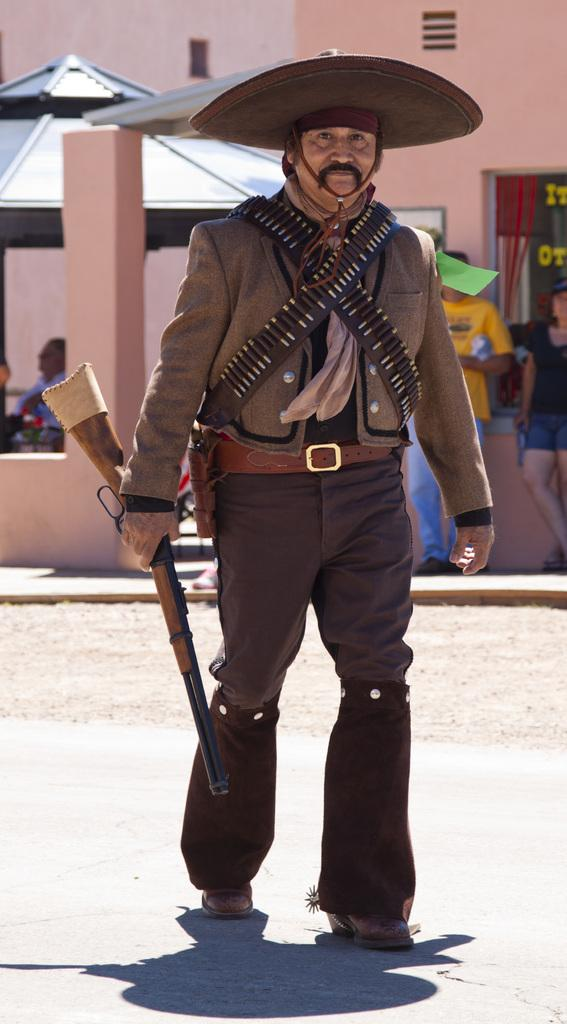What is the person in the image holding? The person is holding a gun in the image. Can you describe the person's attire? The person is wearing a hat in the image. What type of structures can be seen in the image? There is a building and a shed in the image. What else is present in the image besides the person and structures? There are objects and people in the image. What type of harmony is being played by the beast in the image? There is no beast or harmony present in the image; it features a person holding a gun, structures, objects, and people. How many family members can be seen in the image? The image does not depict a family or any family members; it only shows a person holding a gun, structures, objects, and people. 